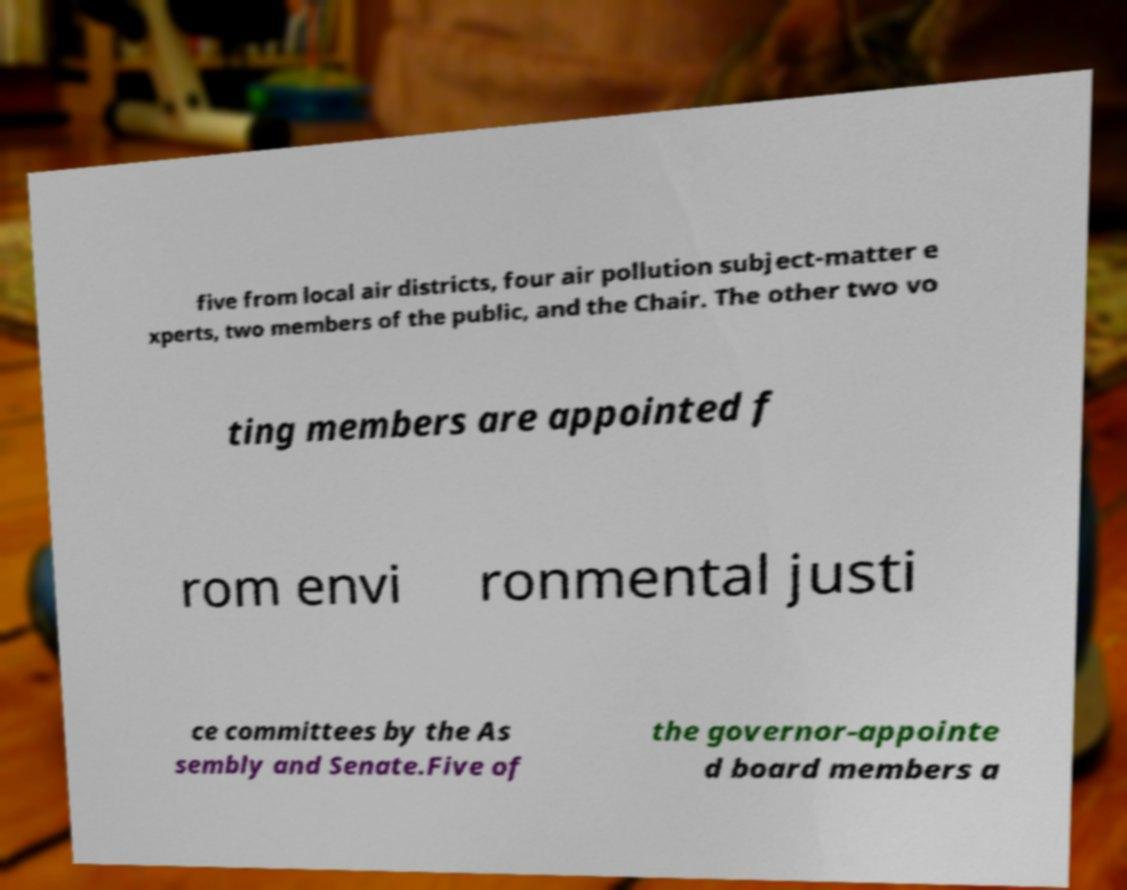What messages or text are displayed in this image? I need them in a readable, typed format. five from local air districts, four air pollution subject-matter e xperts, two members of the public, and the Chair. The other two vo ting members are appointed f rom envi ronmental justi ce committees by the As sembly and Senate.Five of the governor-appointe d board members a 